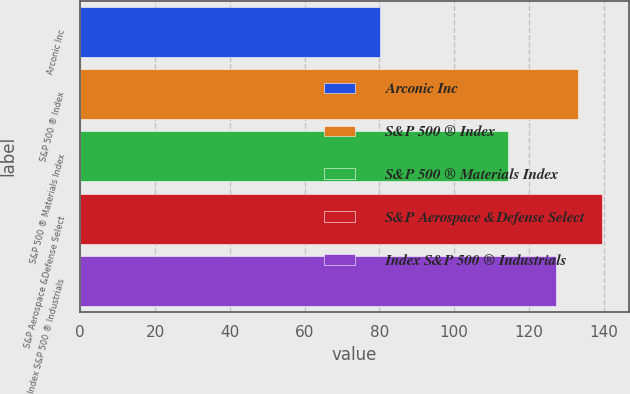Convert chart. <chart><loc_0><loc_0><loc_500><loc_500><bar_chart><fcel>Arconic Inc<fcel>S&P 500 ® Index<fcel>S&P 500 ® Materials Index<fcel>S&P Aerospace &Defense Select<fcel>Index S&P 500 ® Industrials<nl><fcel>80.22<fcel>133.18<fcel>114.3<fcel>139.7<fcel>127.23<nl></chart> 